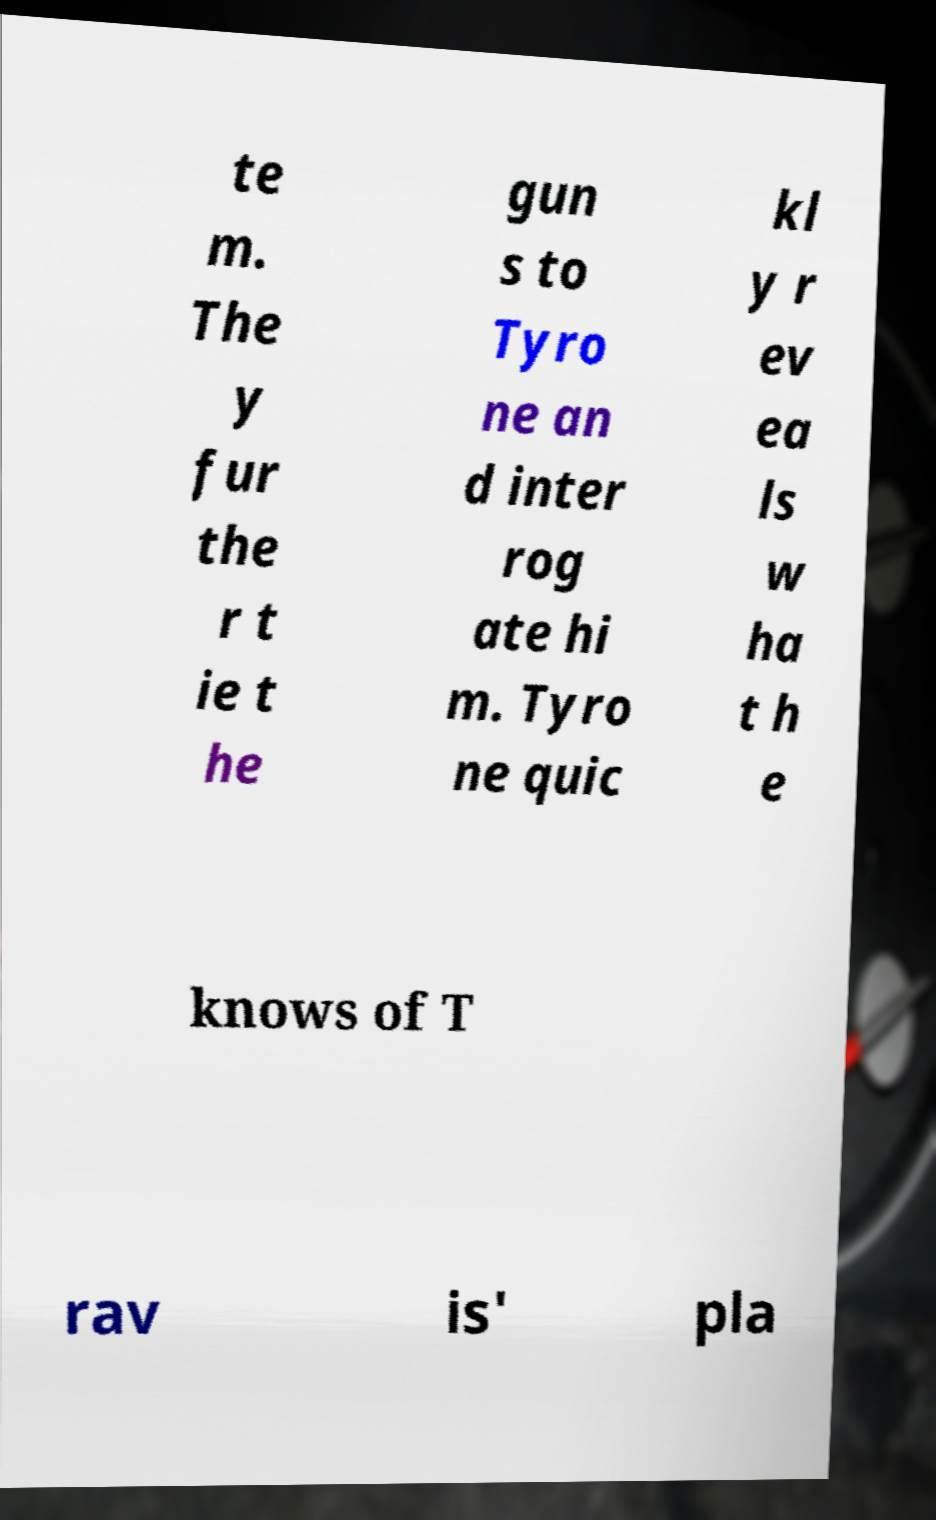For documentation purposes, I need the text within this image transcribed. Could you provide that? te m. The y fur the r t ie t he gun s to Tyro ne an d inter rog ate hi m. Tyro ne quic kl y r ev ea ls w ha t h e knows of T rav is' pla 